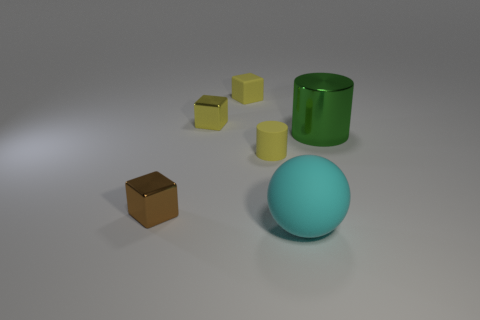Add 2 yellow blocks. How many objects exist? 8 Subtract all green balls. How many yellow cubes are left? 2 Subtract all tiny rubber cubes. How many cubes are left? 2 Subtract all brown cubes. How many cubes are left? 2 Subtract all balls. How many objects are left? 5 Subtract 1 cylinders. How many cylinders are left? 1 Add 3 tiny yellow cubes. How many tiny yellow cubes are left? 5 Add 5 large brown cylinders. How many large brown cylinders exist? 5 Subtract 1 cyan balls. How many objects are left? 5 Subtract all yellow cubes. Subtract all cyan cylinders. How many cubes are left? 1 